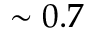Convert formula to latex. <formula><loc_0><loc_0><loc_500><loc_500>\sim 0 . 7</formula> 